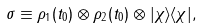Convert formula to latex. <formula><loc_0><loc_0><loc_500><loc_500>\sigma \equiv \rho _ { 1 } ( t _ { 0 } ) \otimes \rho _ { 2 } ( t _ { 0 } ) \otimes | \chi \rangle \langle \chi | ,</formula> 